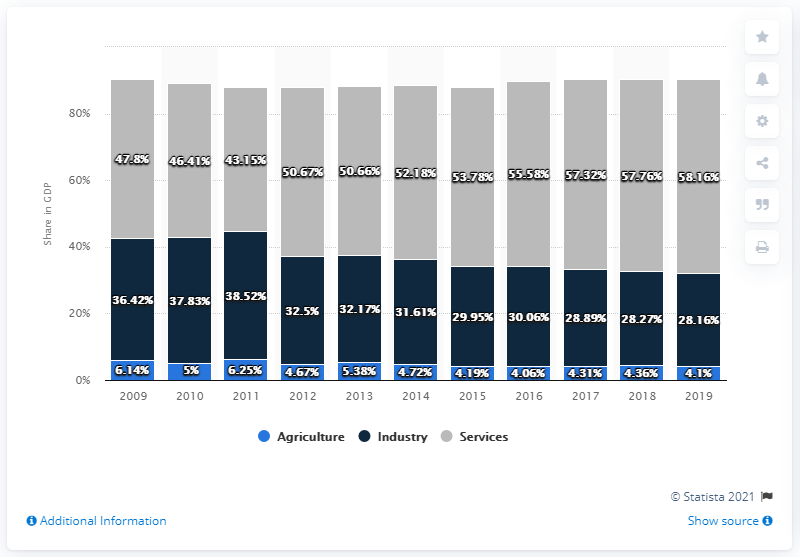Highlight a few significant elements in this photo. In 2019, the share of agriculture in Romania's gross domestic product was 4.1%. The difference between the maximum Gross Domestic Product (GDP) in the agriculture sector and the minimum GDP in the industry has varied over the years, with a range of 21.91 in 2019. In 2011, the GDP in the agriculture sector was at its highest level. 